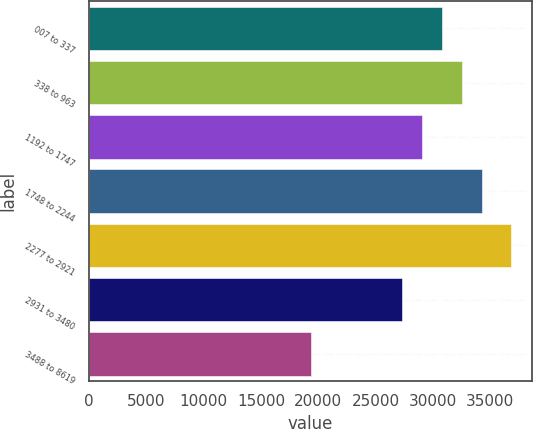Convert chart to OTSL. <chart><loc_0><loc_0><loc_500><loc_500><bar_chart><fcel>007 to 337<fcel>338 to 963<fcel>1192 to 1747<fcel>1748 to 2244<fcel>2277 to 2921<fcel>2931 to 3480<fcel>3488 to 8619<nl><fcel>30810.6<fcel>32556.4<fcel>29064.8<fcel>34302.2<fcel>36792<fcel>27319<fcel>19334<nl></chart> 